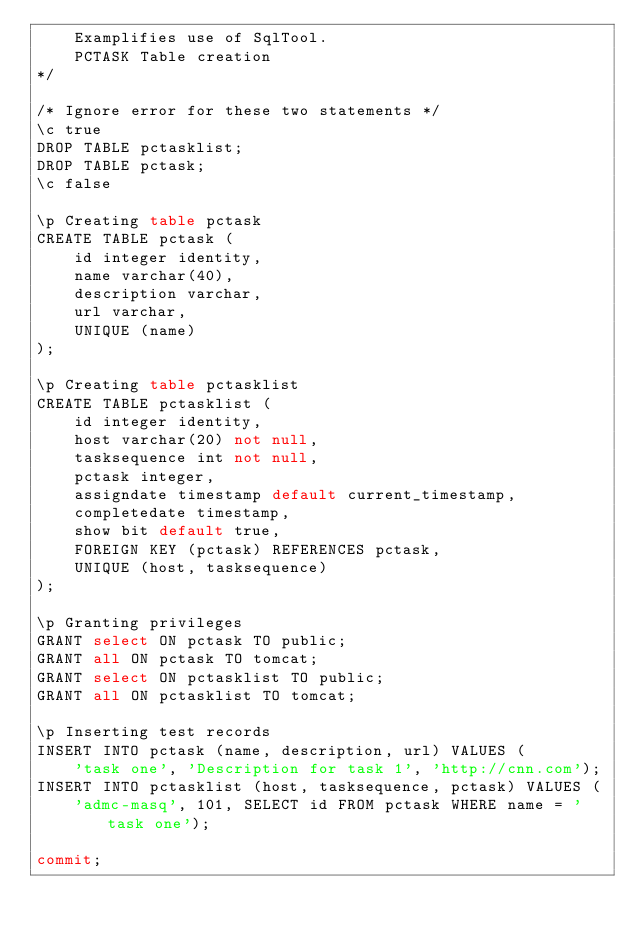Convert code to text. <code><loc_0><loc_0><loc_500><loc_500><_SQL_>    Examplifies use of SqlTool.
    PCTASK Table creation
*/

/* Ignore error for these two statements */
\c true
DROP TABLE pctasklist;
DROP TABLE pctask;
\c false

\p Creating table pctask
CREATE TABLE pctask (
    id integer identity,
    name varchar(40),
    description varchar,
    url varchar,
    UNIQUE (name)
);

\p Creating table pctasklist
CREATE TABLE pctasklist (
    id integer identity,
    host varchar(20) not null,
    tasksequence int not null,
    pctask integer,
    assigndate timestamp default current_timestamp,
    completedate timestamp,
    show bit default true,
    FOREIGN KEY (pctask) REFERENCES pctask,
    UNIQUE (host, tasksequence)
);

\p Granting privileges
GRANT select ON pctask TO public;
GRANT all ON pctask TO tomcat;
GRANT select ON pctasklist TO public;
GRANT all ON pctasklist TO tomcat;

\p Inserting test records
INSERT INTO pctask (name, description, url) VALUES (
    'task one', 'Description for task 1', 'http://cnn.com');
INSERT INTO pctasklist (host, tasksequence, pctask) VALUES (
    'admc-masq', 101, SELECT id FROM pctask WHERE name = 'task one');

commit;
</code> 